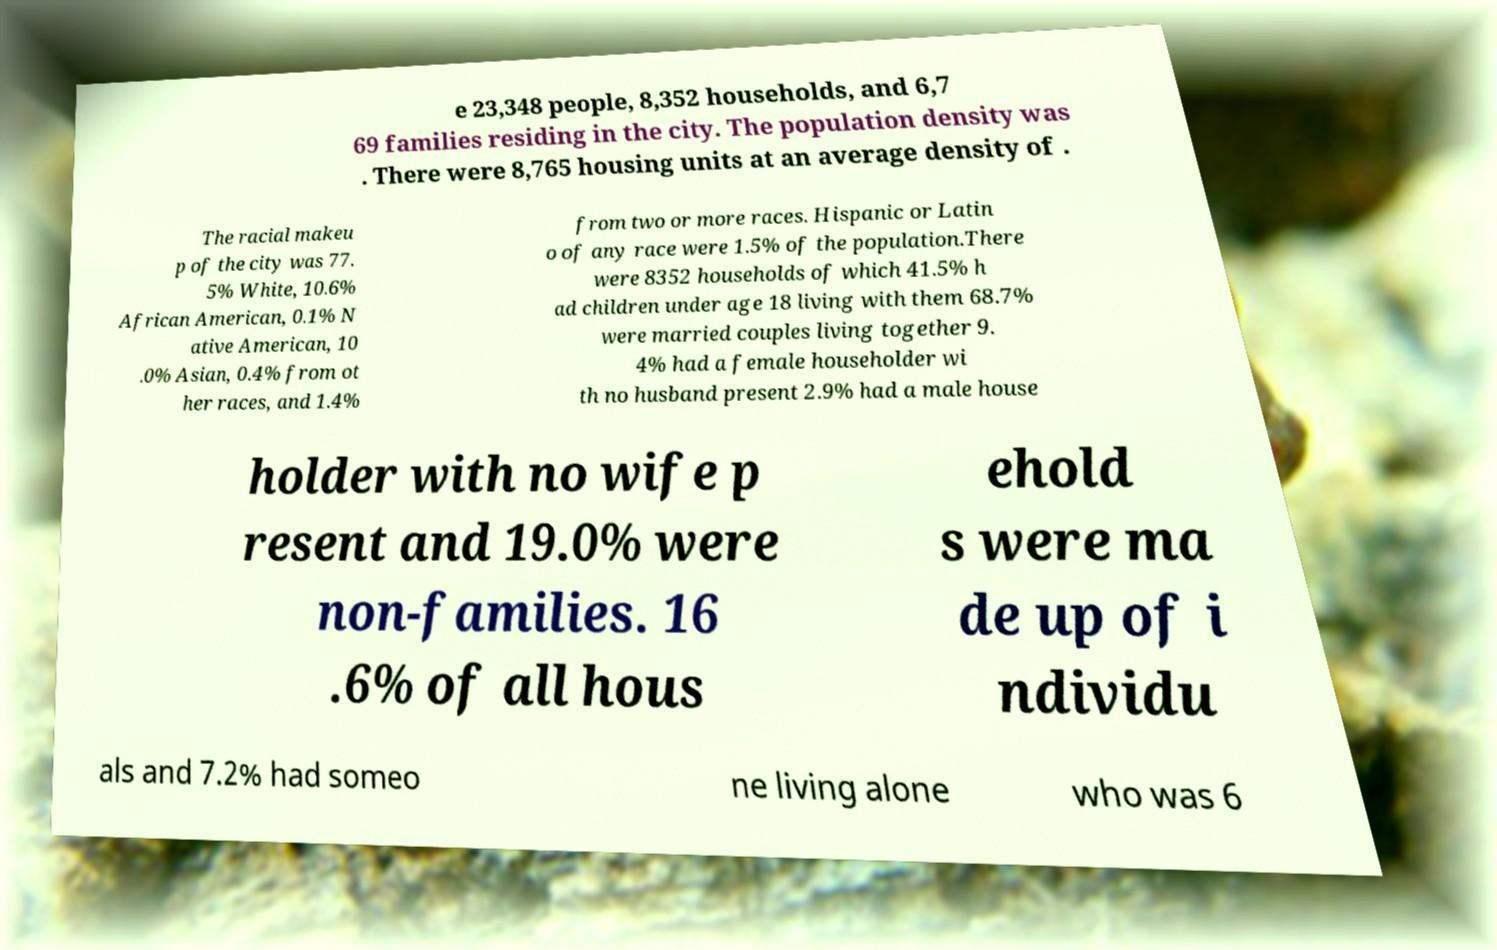Could you assist in decoding the text presented in this image and type it out clearly? e 23,348 people, 8,352 households, and 6,7 69 families residing in the city. The population density was . There were 8,765 housing units at an average density of . The racial makeu p of the city was 77. 5% White, 10.6% African American, 0.1% N ative American, 10 .0% Asian, 0.4% from ot her races, and 1.4% from two or more races. Hispanic or Latin o of any race were 1.5% of the population.There were 8352 households of which 41.5% h ad children under age 18 living with them 68.7% were married couples living together 9. 4% had a female householder wi th no husband present 2.9% had a male house holder with no wife p resent and 19.0% were non-families. 16 .6% of all hous ehold s were ma de up of i ndividu als and 7.2% had someo ne living alone who was 6 